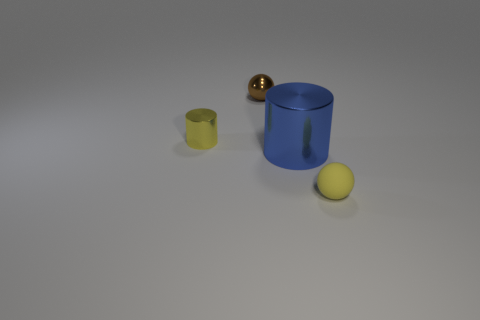Is there a object that is left of the sphere that is behind the tiny yellow object in front of the big metallic cylinder?
Keep it short and to the point. Yes. What color is the big thing that is made of the same material as the small cylinder?
Provide a succinct answer. Blue. There is a cylinder that is left of the tiny metal ball; is its color the same as the tiny rubber sphere?
Give a very brief answer. Yes. What number of blocks are either big yellow matte objects or matte objects?
Offer a terse response. 0. What is the size of the cylinder that is left of the tiny shiny object that is right of the tiny yellow object that is behind the small yellow matte sphere?
Offer a terse response. Small. There is a rubber object that is the same size as the yellow cylinder; what shape is it?
Offer a very short reply. Sphere. There is a rubber thing; what shape is it?
Offer a very short reply. Sphere. Are the yellow thing that is behind the yellow rubber object and the yellow sphere made of the same material?
Give a very brief answer. No. There is a yellow object that is to the right of the small metal thing that is behind the yellow shiny cylinder; what size is it?
Offer a terse response. Small. What color is the object that is both behind the yellow matte ball and on the right side of the small brown metal object?
Give a very brief answer. Blue. 